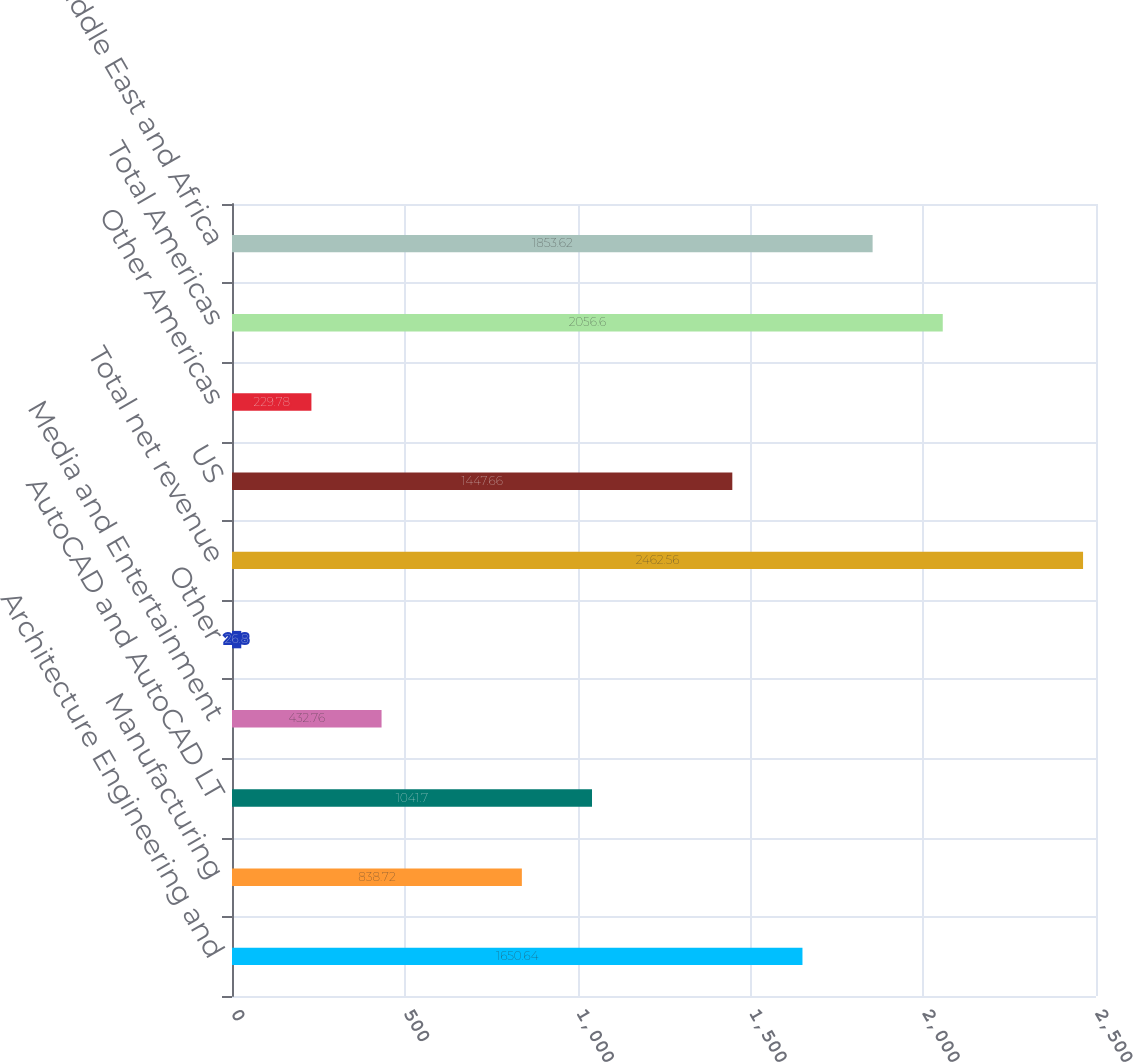Convert chart. <chart><loc_0><loc_0><loc_500><loc_500><bar_chart><fcel>Architecture Engineering and<fcel>Manufacturing<fcel>AutoCAD and AutoCAD LT<fcel>Media and Entertainment<fcel>Other<fcel>Total net revenue<fcel>US<fcel>Other Americas<fcel>Total Americas<fcel>Europe Middle East and Africa<nl><fcel>1650.64<fcel>838.72<fcel>1041.7<fcel>432.76<fcel>26.8<fcel>2462.56<fcel>1447.66<fcel>229.78<fcel>2056.6<fcel>1853.62<nl></chart> 